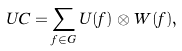<formula> <loc_0><loc_0><loc_500><loc_500>\ U C = \sum _ { f \in G } U ( f ) \otimes W ( f ) ,</formula> 